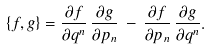Convert formula to latex. <formula><loc_0><loc_0><loc_500><loc_500>\left \{ f , g \right \} = \frac { \partial f } { \partial q ^ { n } } \, \frac { \partial g } { \partial p _ { n } } \, - \, \frac { \partial f } { \partial p _ { n } } \, \frac { \partial g } { \partial q ^ { n } } .</formula> 